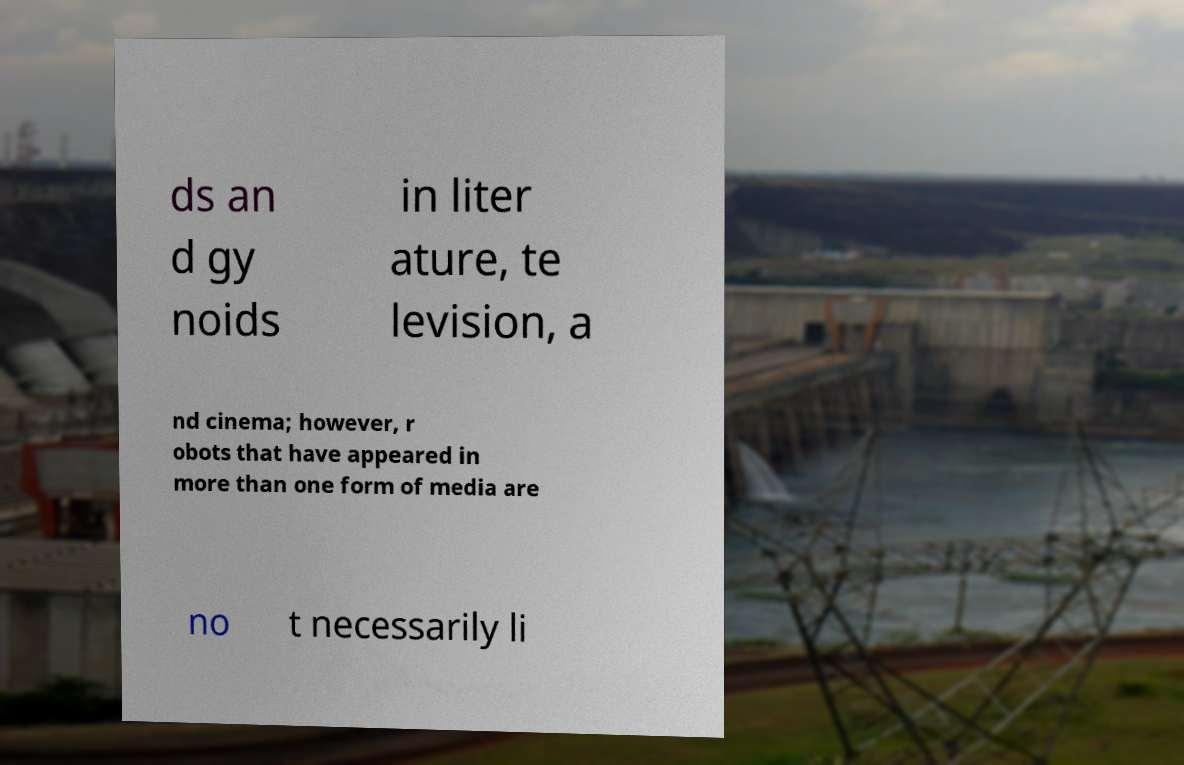Please read and relay the text visible in this image. What does it say? ds an d gy noids in liter ature, te levision, a nd cinema; however, r obots that have appeared in more than one form of media are no t necessarily li 